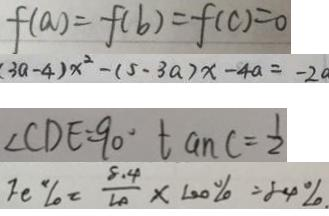<formula> <loc_0><loc_0><loc_500><loc_500>f ( a ) = f ( b ) = f ( c ) = 0 
 ( 3 a - 4 ) x ^ { 2 } - ( 5 - 3 a ) x - 4 a = - 2 a 
 \angle C D E = 9 0 ^ { \circ } \tan C = \frac { 1 } { 2 } 
 F e \% = \frac { 8 . 4 } { 1 0 } \times 1 0 0 \% = 8 4 \%</formula> 